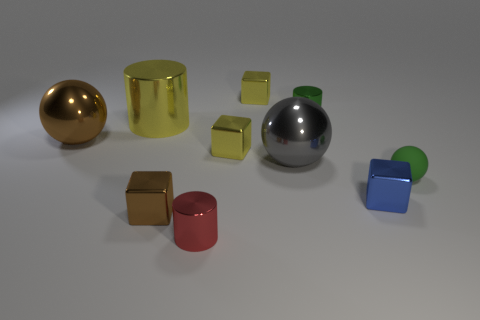Subtract all gray balls. How many yellow blocks are left? 2 Subtract all small shiny cylinders. How many cylinders are left? 1 Subtract 2 blocks. How many blocks are left? 2 Subtract all blocks. How many objects are left? 6 Subtract all purple spheres. Subtract all blue cylinders. How many spheres are left? 3 Subtract all big metal spheres. Subtract all tiny purple rubber cylinders. How many objects are left? 8 Add 2 brown objects. How many brown objects are left? 4 Add 2 red metal cylinders. How many red metal cylinders exist? 3 Subtract all brown blocks. How many blocks are left? 3 Subtract 1 brown balls. How many objects are left? 9 